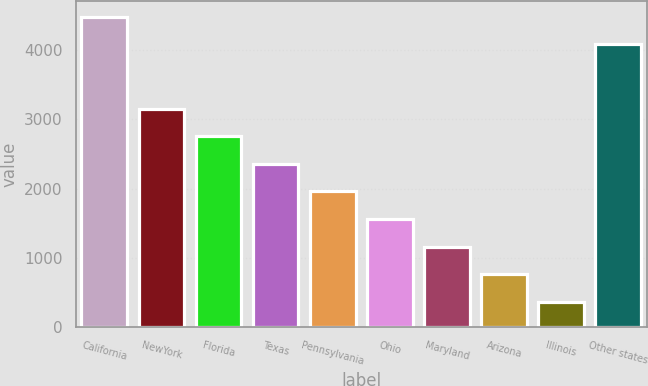<chart> <loc_0><loc_0><loc_500><loc_500><bar_chart><fcel>California<fcel>NewYork<fcel>Florida<fcel>Texas<fcel>Pennsylvania<fcel>Ohio<fcel>Maryland<fcel>Arizona<fcel>Illinois<fcel>Other states<nl><fcel>4484.5<fcel>3158.5<fcel>2759<fcel>2359.5<fcel>1960<fcel>1560.5<fcel>1161<fcel>761.5<fcel>362<fcel>4085<nl></chart> 